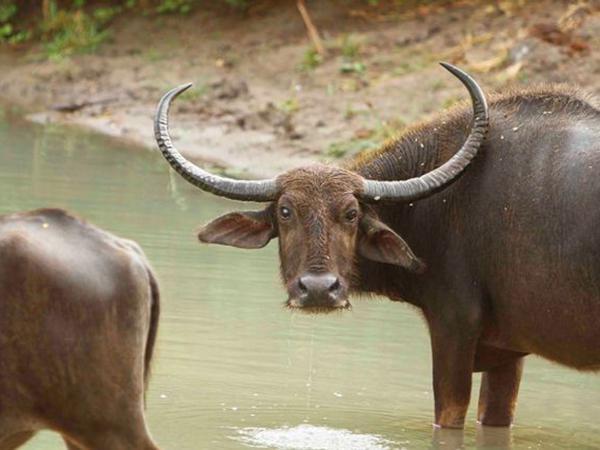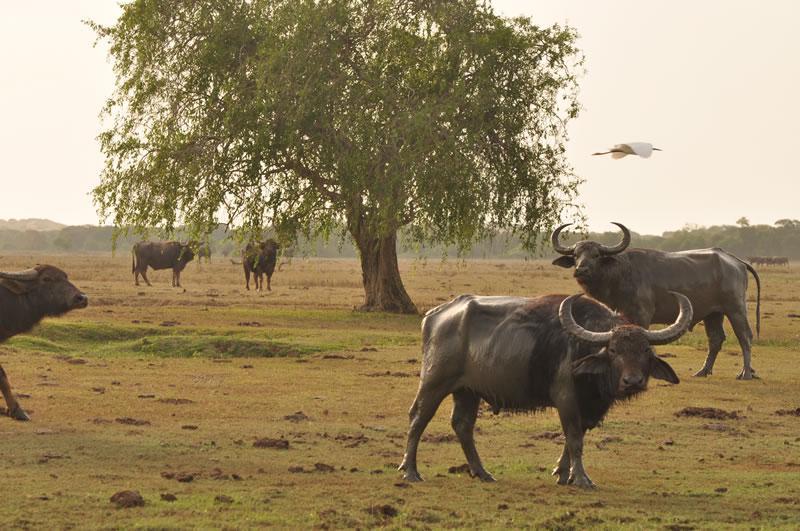The first image is the image on the left, the second image is the image on the right. Given the left and right images, does the statement "Two animals are standing in the water." hold true? Answer yes or no. Yes. 